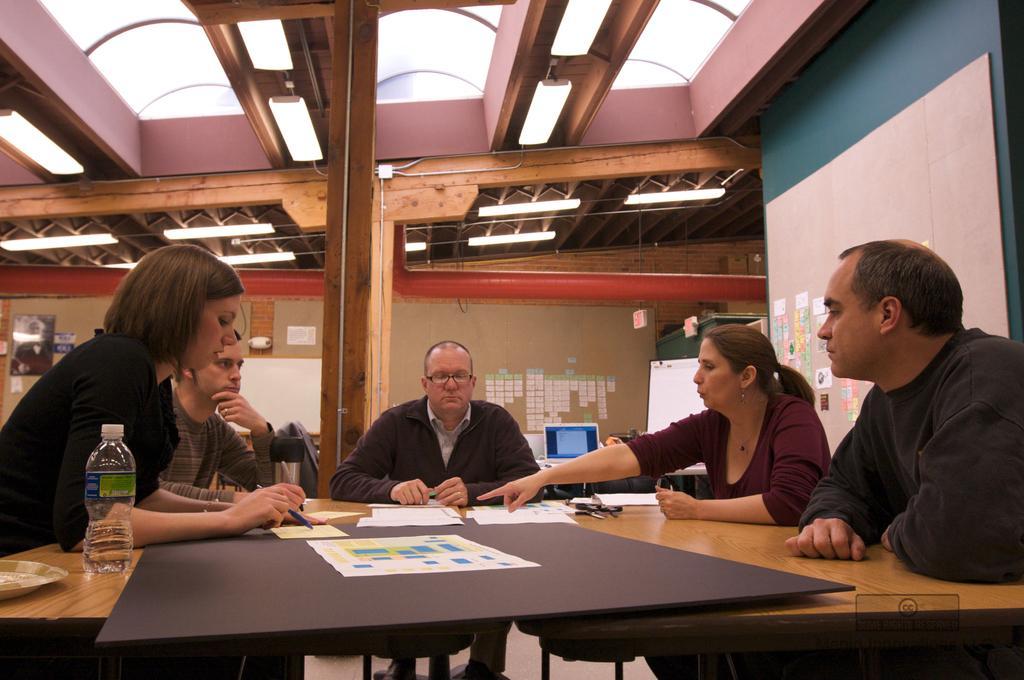Please provide a concise description of this image. there are 5 people sitting. on the table there are papers and bottle 